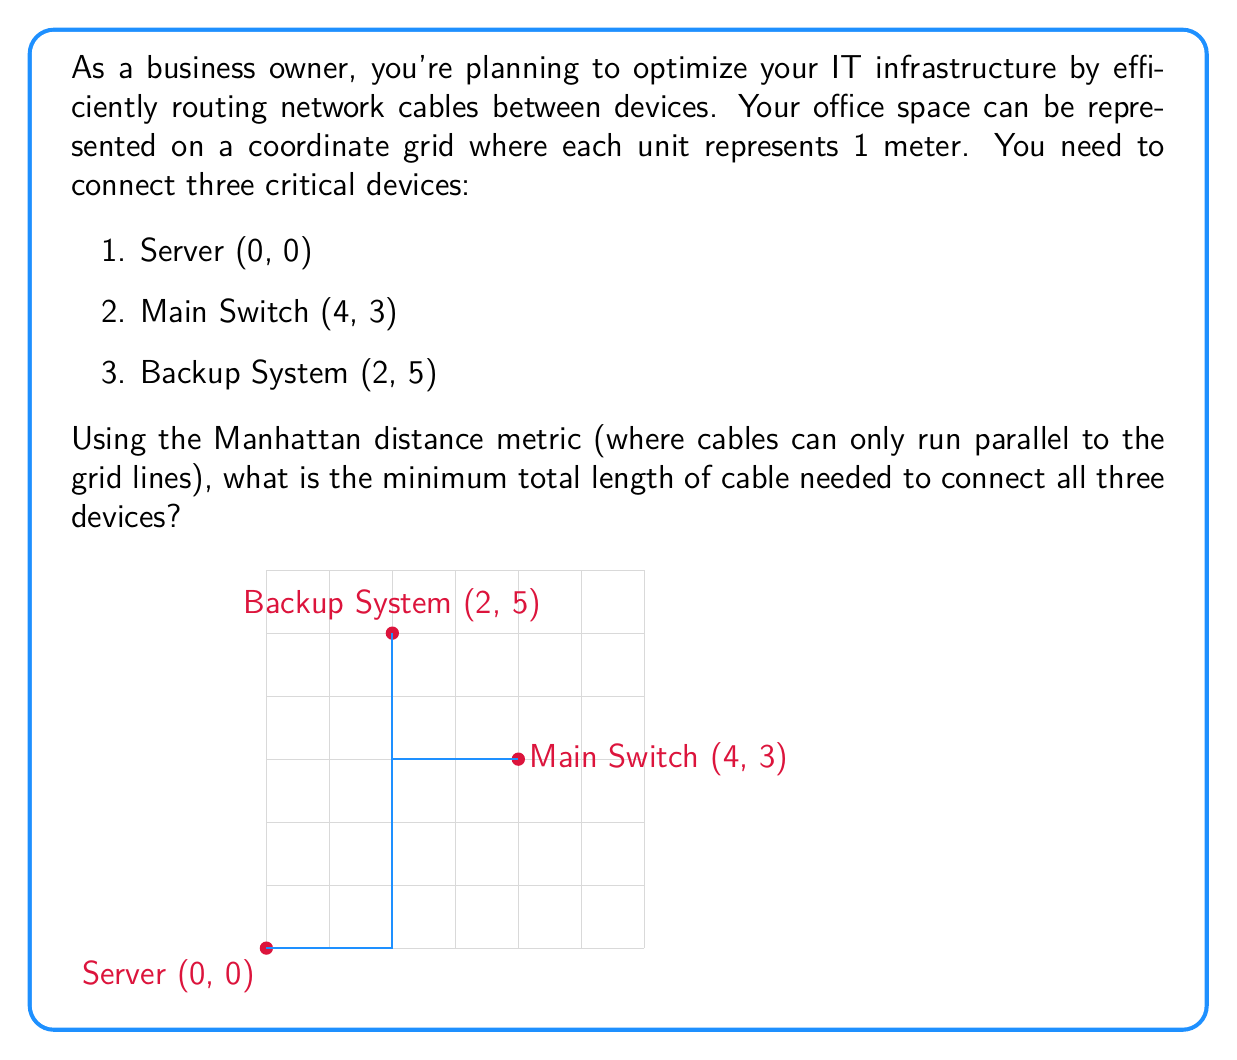Give your solution to this math problem. To solve this problem, we'll use the concept of the Manhattan distance and find the shortest path that connects all three devices.

Step 1: Calculate the distances between each pair of devices.

1. Server to Main Switch:
   $|0-4| + |0-3| = 4 + 3 = 7$ meters

2. Server to Backup System:
   $|0-2| + |0-5| = 2 + 5 = 7$ meters

3. Main Switch to Backup System:
   $|4-2| + |3-5| = 2 + 2 = 4$ meters

Step 2: Identify the optimal path.
The shortest path will connect all three devices using the minimum total distance. We can see that the Main Switch is positioned between the Server and the Backup System.

Step 3: Calculate the minimum cable length.
We can connect the devices in the following order:
Server -> Main Switch -> Backup System

Total length = (Server to Main Switch) + (Main Switch to Backup System)
             = 7 + 4 = 11 meters

This path ensures that all devices are connected with the minimum total cable length.
Answer: 11 meters 